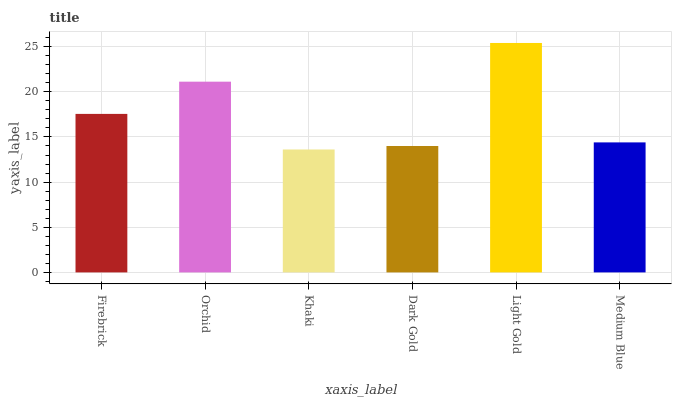Is Orchid the minimum?
Answer yes or no. No. Is Orchid the maximum?
Answer yes or no. No. Is Orchid greater than Firebrick?
Answer yes or no. Yes. Is Firebrick less than Orchid?
Answer yes or no. Yes. Is Firebrick greater than Orchid?
Answer yes or no. No. Is Orchid less than Firebrick?
Answer yes or no. No. Is Firebrick the high median?
Answer yes or no. Yes. Is Medium Blue the low median?
Answer yes or no. Yes. Is Medium Blue the high median?
Answer yes or no. No. Is Dark Gold the low median?
Answer yes or no. No. 